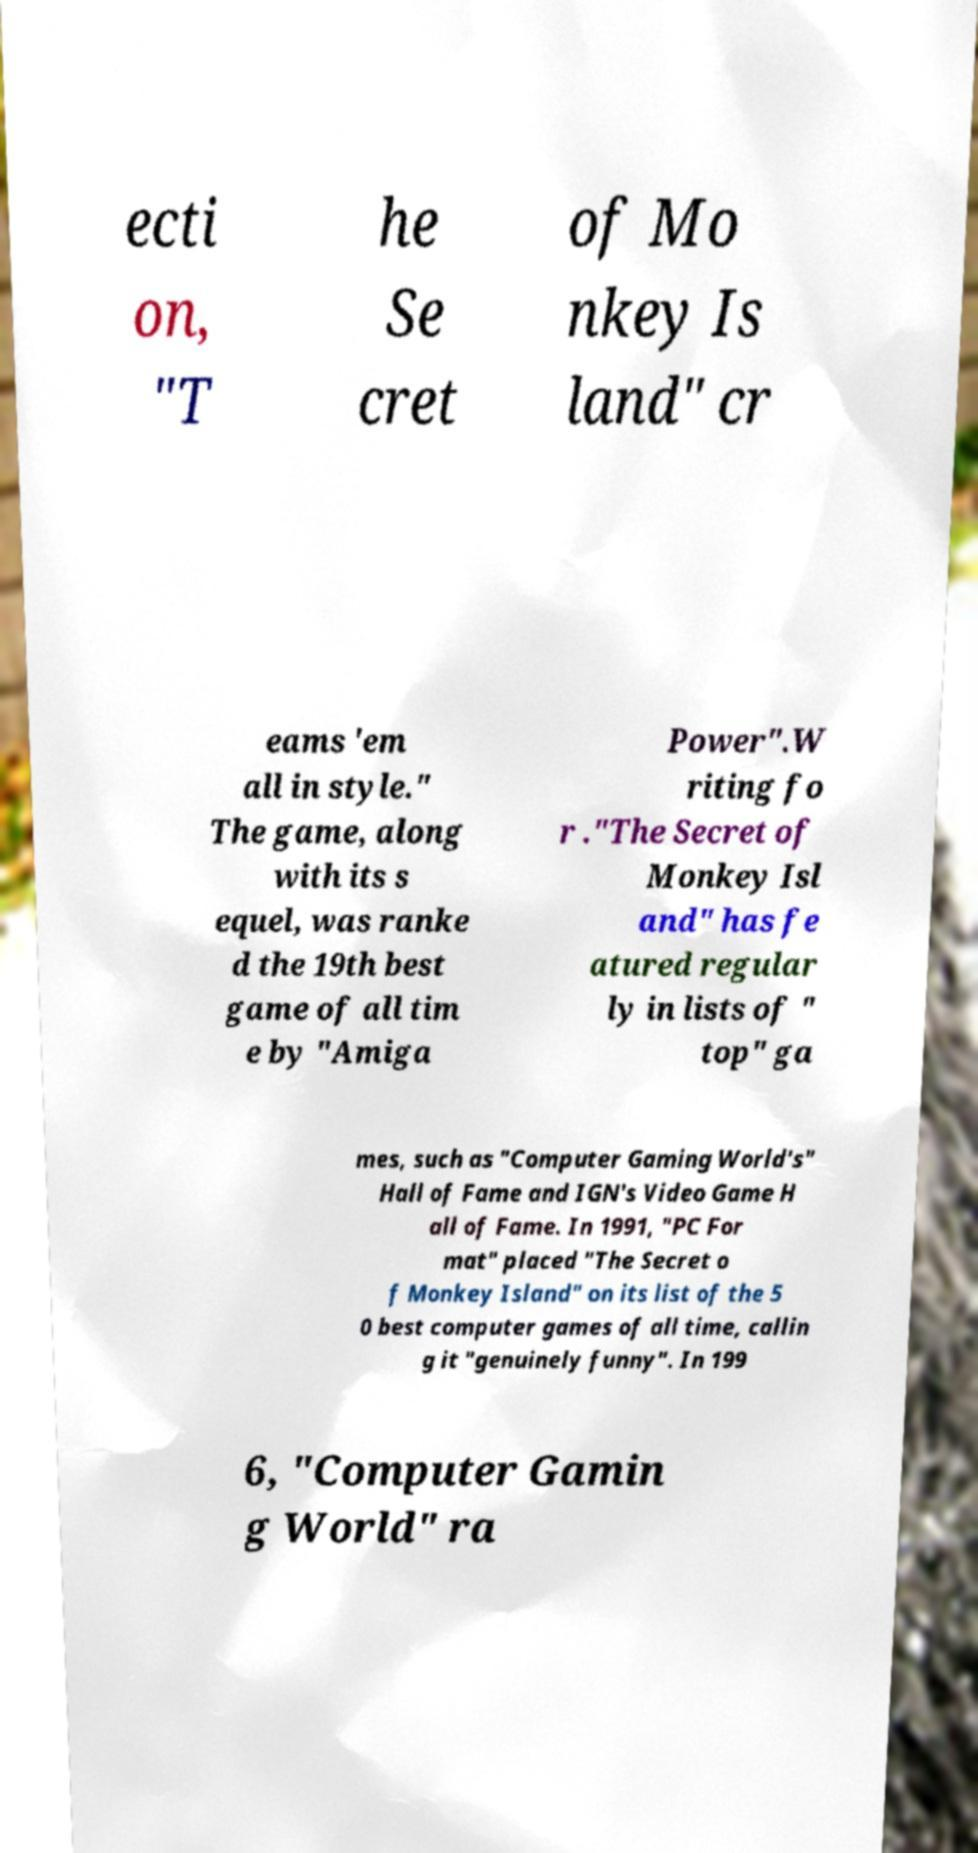Could you extract and type out the text from this image? ecti on, "T he Se cret of Mo nkey Is land" cr eams 'em all in style." The game, along with its s equel, was ranke d the 19th best game of all tim e by "Amiga Power".W riting fo r ."The Secret of Monkey Isl and" has fe atured regular ly in lists of " top" ga mes, such as "Computer Gaming World's" Hall of Fame and IGN's Video Game H all of Fame. In 1991, "PC For mat" placed "The Secret o f Monkey Island" on its list of the 5 0 best computer games of all time, callin g it "genuinely funny". In 199 6, "Computer Gamin g World" ra 